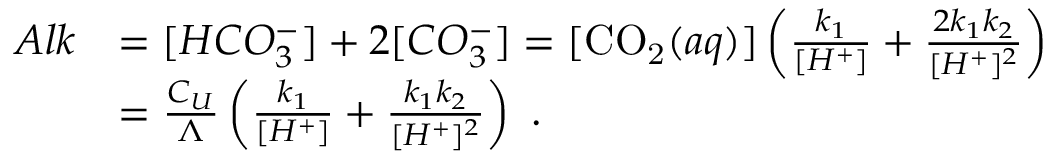Convert formula to latex. <formula><loc_0><loc_0><loc_500><loc_500>\begin{array} { r l } { A l k } & { = [ H C O _ { 3 } ^ { - } ] + 2 [ C O _ { 3 } ^ { - } ] = [ { C O _ { 2 } } ( a q ) ] \left ( \frac { k _ { 1 } } { [ H ^ { + } ] } + \frac { 2 k _ { 1 } k _ { 2 } } { [ H ^ { + } ] ^ { 2 } } \right ) } \\ & { = \frac { C _ { U } } { \Lambda } \left ( \frac { k _ { 1 } } { [ H ^ { + } ] } + \frac { k _ { 1 } k _ { 2 } } { [ H ^ { + } ] ^ { 2 } } \right ) . } \end{array}</formula> 